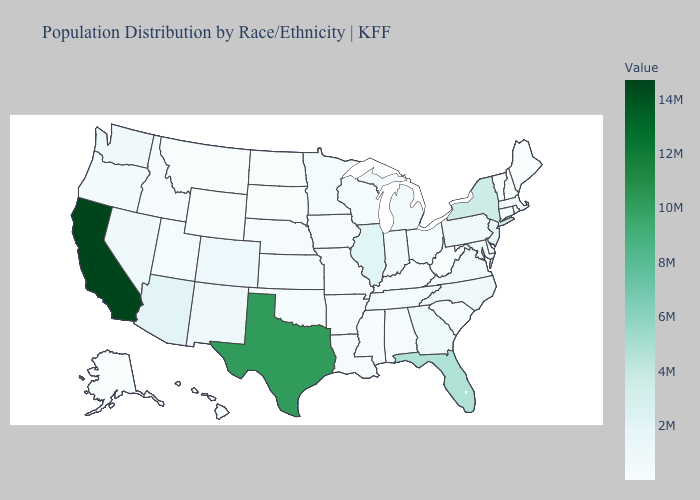Does West Virginia have the lowest value in the South?
Answer briefly. Yes. Does the map have missing data?
Answer briefly. No. Among the states that border Montana , which have the lowest value?
Be succinct. North Dakota. Among the states that border North Dakota , does Montana have the lowest value?
Quick response, please. No. Which states hav the highest value in the Northeast?
Give a very brief answer. New York. Which states have the highest value in the USA?
Short answer required. California. Does West Virginia have the lowest value in the South?
Give a very brief answer. Yes. 